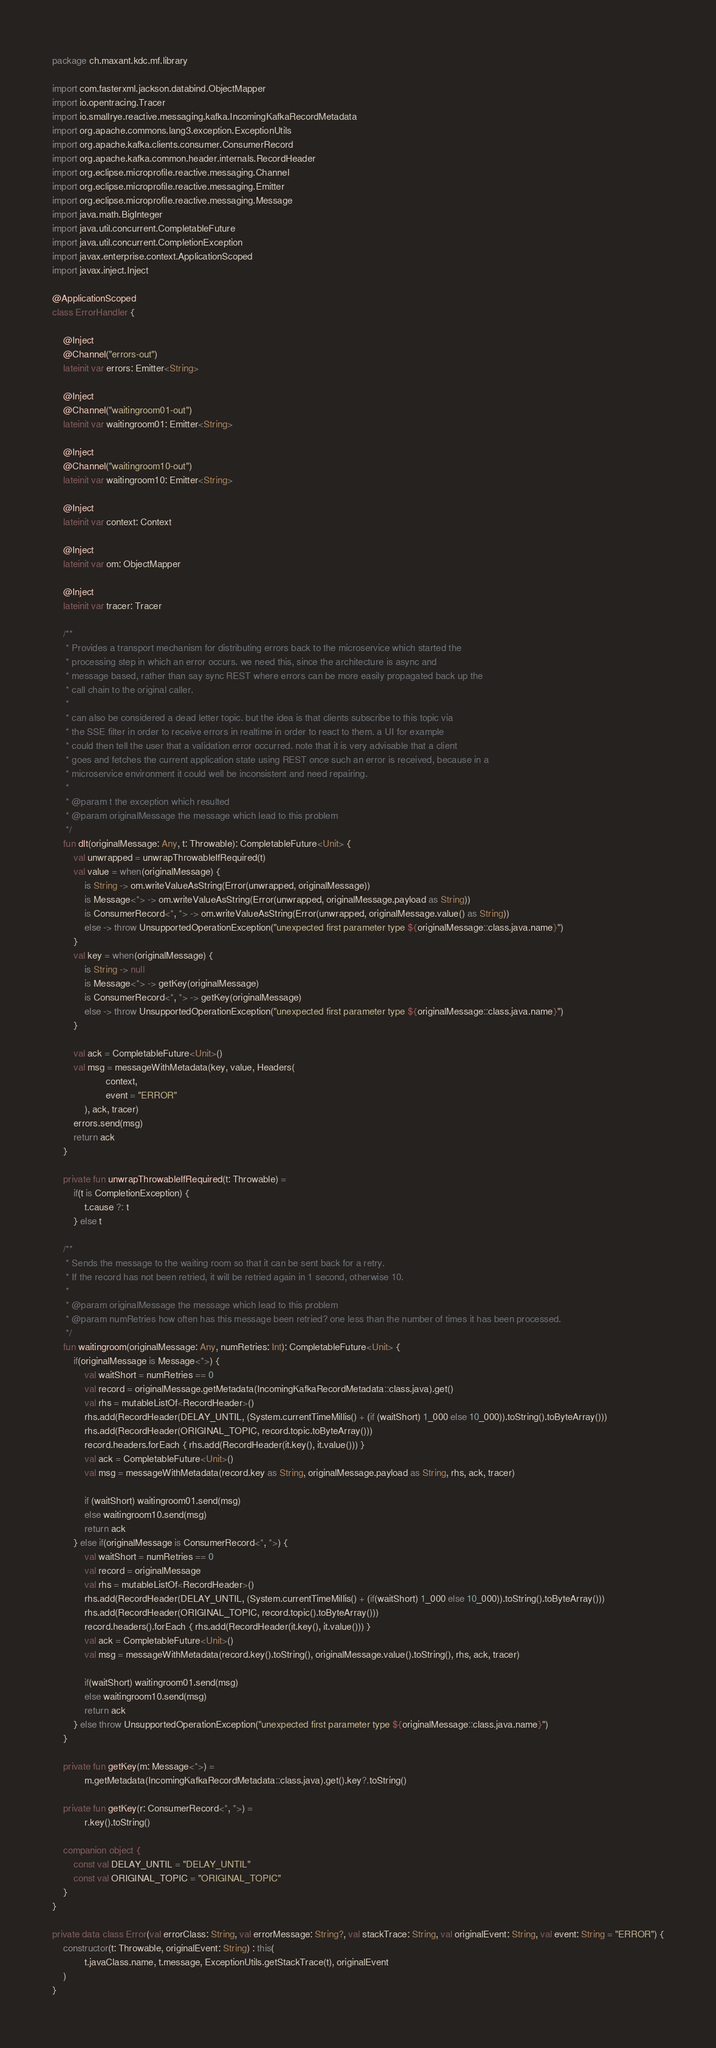Convert code to text. <code><loc_0><loc_0><loc_500><loc_500><_Kotlin_>package ch.maxant.kdc.mf.library

import com.fasterxml.jackson.databind.ObjectMapper
import io.opentracing.Tracer
import io.smallrye.reactive.messaging.kafka.IncomingKafkaRecordMetadata
import org.apache.commons.lang3.exception.ExceptionUtils
import org.apache.kafka.clients.consumer.ConsumerRecord
import org.apache.kafka.common.header.internals.RecordHeader
import org.eclipse.microprofile.reactive.messaging.Channel
import org.eclipse.microprofile.reactive.messaging.Emitter
import org.eclipse.microprofile.reactive.messaging.Message
import java.math.BigInteger
import java.util.concurrent.CompletableFuture
import java.util.concurrent.CompletionException
import javax.enterprise.context.ApplicationScoped
import javax.inject.Inject

@ApplicationScoped
class ErrorHandler {

    @Inject
    @Channel("errors-out")
    lateinit var errors: Emitter<String>

    @Inject
    @Channel("waitingroom01-out")
    lateinit var waitingroom01: Emitter<String>

    @Inject
    @Channel("waitingroom10-out")
    lateinit var waitingroom10: Emitter<String>

    @Inject
    lateinit var context: Context

    @Inject
    lateinit var om: ObjectMapper

    @Inject
    lateinit var tracer: Tracer

    /**
     * Provides a transport mechanism for distributing errors back to the microservice which started the
     * processing step in which an error occurs. we need this, since the architecture is async and
     * message based, rather than say sync REST where errors can be more easily propagated back up the
     * call chain to the original caller.
     *
     * can also be considered a dead letter topic. but the idea is that clients subscribe to this topic via
     * the SSE filter in order to receive errors in realtime in order to react to them. a UI for example
     * could then tell the user that a validation error occurred. note that it is very advisable that a client
     * goes and fetches the current application state using REST once such an error is received, because in a
     * microservice environment it could well be inconsistent and need repairing.
     *
     * @param t the exception which resulted
     * @param originalMessage the message which lead to this problem
     */
    fun dlt(originalMessage: Any, t: Throwable): CompletableFuture<Unit> {
        val unwrapped = unwrapThrowableIfRequired(t)
        val value = when(originalMessage) {
            is String -> om.writeValueAsString(Error(unwrapped, originalMessage))
            is Message<*> -> om.writeValueAsString(Error(unwrapped, originalMessage.payload as String))
            is ConsumerRecord<*, *> -> om.writeValueAsString(Error(unwrapped, originalMessage.value() as String))
            else -> throw UnsupportedOperationException("unexpected first parameter type ${originalMessage::class.java.name}")
        }
        val key = when(originalMessage) {
            is String -> null
            is Message<*> -> getKey(originalMessage)
            is ConsumerRecord<*, *> -> getKey(originalMessage)
            else -> throw UnsupportedOperationException("unexpected first parameter type ${originalMessage::class.java.name}")
        }

        val ack = CompletableFuture<Unit>()
        val msg = messageWithMetadata(key, value, Headers(
                    context,
                    event = "ERROR"
            ), ack, tracer)
        errors.send(msg)
        return ack
    }

    private fun unwrapThrowableIfRequired(t: Throwable) =
        if(t is CompletionException) {
            t.cause ?: t
        } else t

    /**
     * Sends the message to the waiting room so that it can be sent back for a retry.
     * If the record has not been retried, it will be retried again in 1 second, otherwise 10.
     *
     * @param originalMessage the message which lead to this problem
     * @param numRetries how often has this message been retried? one less than the number of times it has been processed.
     */
    fun waitingroom(originalMessage: Any, numRetries: Int): CompletableFuture<Unit> {
        if(originalMessage is Message<*>) {
            val waitShort = numRetries == 0
            val record = originalMessage.getMetadata(IncomingKafkaRecordMetadata::class.java).get()
            val rhs = mutableListOf<RecordHeader>()
            rhs.add(RecordHeader(DELAY_UNTIL, (System.currentTimeMillis() + (if (waitShort) 1_000 else 10_000)).toString().toByteArray()))
            rhs.add(RecordHeader(ORIGINAL_TOPIC, record.topic.toByteArray()))
            record.headers.forEach { rhs.add(RecordHeader(it.key(), it.value())) }
            val ack = CompletableFuture<Unit>()
            val msg = messageWithMetadata(record.key as String, originalMessage.payload as String, rhs, ack, tracer)

            if (waitShort) waitingroom01.send(msg)
            else waitingroom10.send(msg)
            return ack
        } else if(originalMessage is ConsumerRecord<*, *>) {
            val waitShort = numRetries == 0
            val record = originalMessage
            val rhs = mutableListOf<RecordHeader>()
            rhs.add(RecordHeader(DELAY_UNTIL, (System.currentTimeMillis() + (if(waitShort) 1_000 else 10_000)).toString().toByteArray()))
            rhs.add(RecordHeader(ORIGINAL_TOPIC, record.topic().toByteArray()))
            record.headers().forEach { rhs.add(RecordHeader(it.key(), it.value())) }
            val ack = CompletableFuture<Unit>()
            val msg = messageWithMetadata(record.key().toString(), originalMessage.value().toString(), rhs, ack, tracer)

            if(waitShort) waitingroom01.send(msg)
            else waitingroom10.send(msg)
            return ack
        } else throw UnsupportedOperationException("unexpected first parameter type ${originalMessage::class.java.name}")
    }

    private fun getKey(m: Message<*>) =
            m.getMetadata(IncomingKafkaRecordMetadata::class.java).get().key?.toString()

    private fun getKey(r: ConsumerRecord<*, *>) =
            r.key().toString()

    companion object {
        const val DELAY_UNTIL = "DELAY_UNTIL"
        const val ORIGINAL_TOPIC = "ORIGINAL_TOPIC"
    }
}

private data class Error(val errorClass: String, val errorMessage: String?, val stackTrace: String, val originalEvent: String, val event: String = "ERROR") {
    constructor(t: Throwable, originalEvent: String) : this(
            t.javaClass.name, t.message, ExceptionUtils.getStackTrace(t), originalEvent
    )
}
</code> 